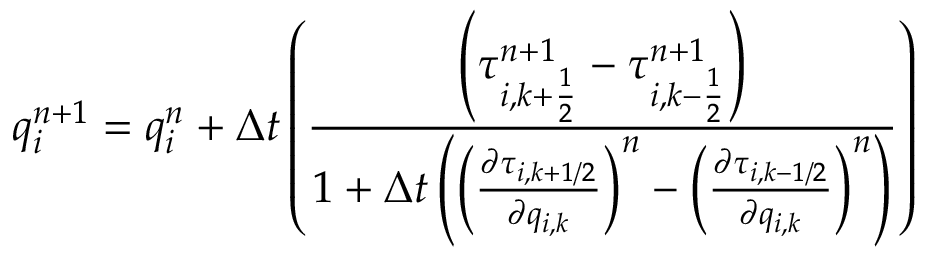<formula> <loc_0><loc_0><loc_500><loc_500>q _ { i } ^ { n + 1 } = q _ { i } ^ { n } + \Delta t \left ( \frac { \left ( \tau _ { i , k + \frac { 1 } { 2 } } ^ { n + 1 } - \tau _ { i , k - \frac { 1 } { 2 } } ^ { n + 1 } \right ) } { 1 + \Delta t \left ( \left ( \frac { \partial \tau _ { i , k + 1 / 2 } } { \partial q _ { i , k } } \right ) ^ { n } - \left ( \frac { \partial \tau _ { i , k - 1 / 2 } } { \partial q _ { i , k } } \right ) ^ { n } \right ) } \right )</formula> 